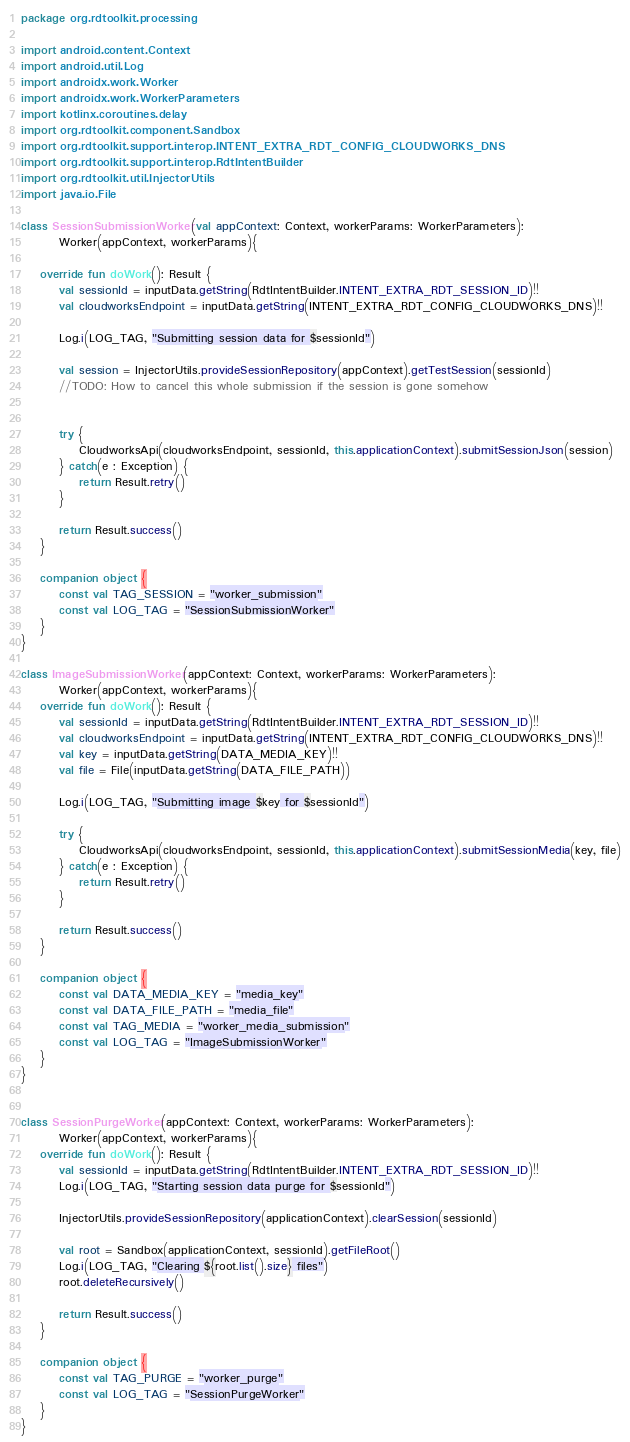Convert code to text. <code><loc_0><loc_0><loc_500><loc_500><_Kotlin_>package org.rdtoolkit.processing

import android.content.Context
import android.util.Log
import androidx.work.Worker
import androidx.work.WorkerParameters
import kotlinx.coroutines.delay
import org.rdtoolkit.component.Sandbox
import org.rdtoolkit.support.interop.INTENT_EXTRA_RDT_CONFIG_CLOUDWORKS_DNS
import org.rdtoolkit.support.interop.RdtIntentBuilder
import org.rdtoolkit.util.InjectorUtils
import java.io.File

class SessionSubmissionWorker(val appContext: Context, workerParams: WorkerParameters):
        Worker(appContext, workerParams){

    override fun doWork(): Result {
        val sessionId = inputData.getString(RdtIntentBuilder.INTENT_EXTRA_RDT_SESSION_ID)!!
        val cloudworksEndpoint = inputData.getString(INTENT_EXTRA_RDT_CONFIG_CLOUDWORKS_DNS)!!

        Log.i(LOG_TAG, "Submitting session data for $sessionId")

        val session = InjectorUtils.provideSessionRepository(appContext).getTestSession(sessionId)
        //TODO: How to cancel this whole submission if the session is gone somehow


        try {
            CloudworksApi(cloudworksEndpoint, sessionId, this.applicationContext).submitSessionJson(session)
        } catch(e : Exception) {
            return Result.retry()
        }

        return Result.success()
    }

    companion object {
        const val TAG_SESSION = "worker_submission"
        const val LOG_TAG = "SessionSubmissionWorker"
    }
}

class ImageSubmissionWorker(appContext: Context, workerParams: WorkerParameters):
        Worker(appContext, workerParams){
    override fun doWork(): Result {
        val sessionId = inputData.getString(RdtIntentBuilder.INTENT_EXTRA_RDT_SESSION_ID)!!
        val cloudworksEndpoint = inputData.getString(INTENT_EXTRA_RDT_CONFIG_CLOUDWORKS_DNS)!!
        val key = inputData.getString(DATA_MEDIA_KEY)!!
        val file = File(inputData.getString(DATA_FILE_PATH))

        Log.i(LOG_TAG, "Submitting image $key for $sessionId")

        try {
            CloudworksApi(cloudworksEndpoint, sessionId, this.applicationContext).submitSessionMedia(key, file)
        } catch(e : Exception) {
            return Result.retry()
        }

        return Result.success()
    }

    companion object {
        const val DATA_MEDIA_KEY = "media_key"
        const val DATA_FILE_PATH = "media_file"
        const val TAG_MEDIA = "worker_media_submission"
        const val LOG_TAG = "ImageSubmissionWorker"
    }
}


class SessionPurgeWorker(appContext: Context, workerParams: WorkerParameters):
        Worker(appContext, workerParams){
    override fun doWork(): Result {
        val sessionId = inputData.getString(RdtIntentBuilder.INTENT_EXTRA_RDT_SESSION_ID)!!
        Log.i(LOG_TAG, "Starting session data purge for $sessionId")

        InjectorUtils.provideSessionRepository(applicationContext).clearSession(sessionId)

        val root = Sandbox(applicationContext, sessionId).getFileRoot()
        Log.i(LOG_TAG, "Clearing ${root.list().size} files")
        root.deleteRecursively()

        return Result.success()
    }

    companion object {
        const val TAG_PURGE = "worker_purge"
        const val LOG_TAG = "SessionPurgeWorker"
    }
}
</code> 